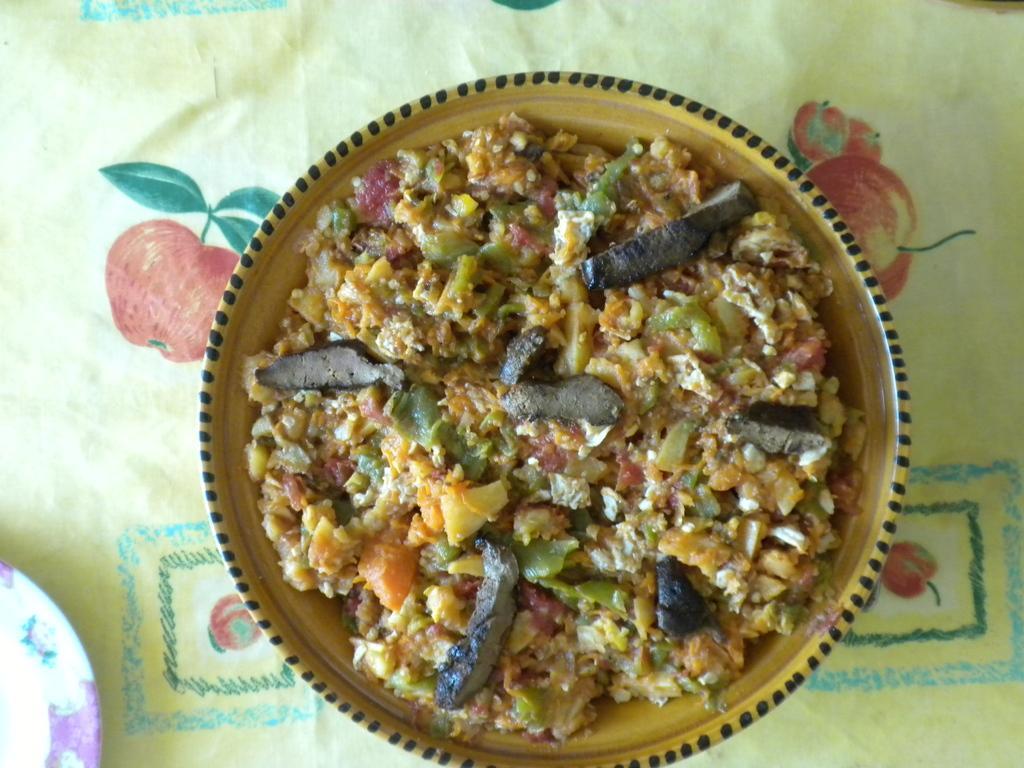Can you describe this image briefly? In this image there is a food item on the plate and there is another plate on the cloth. 